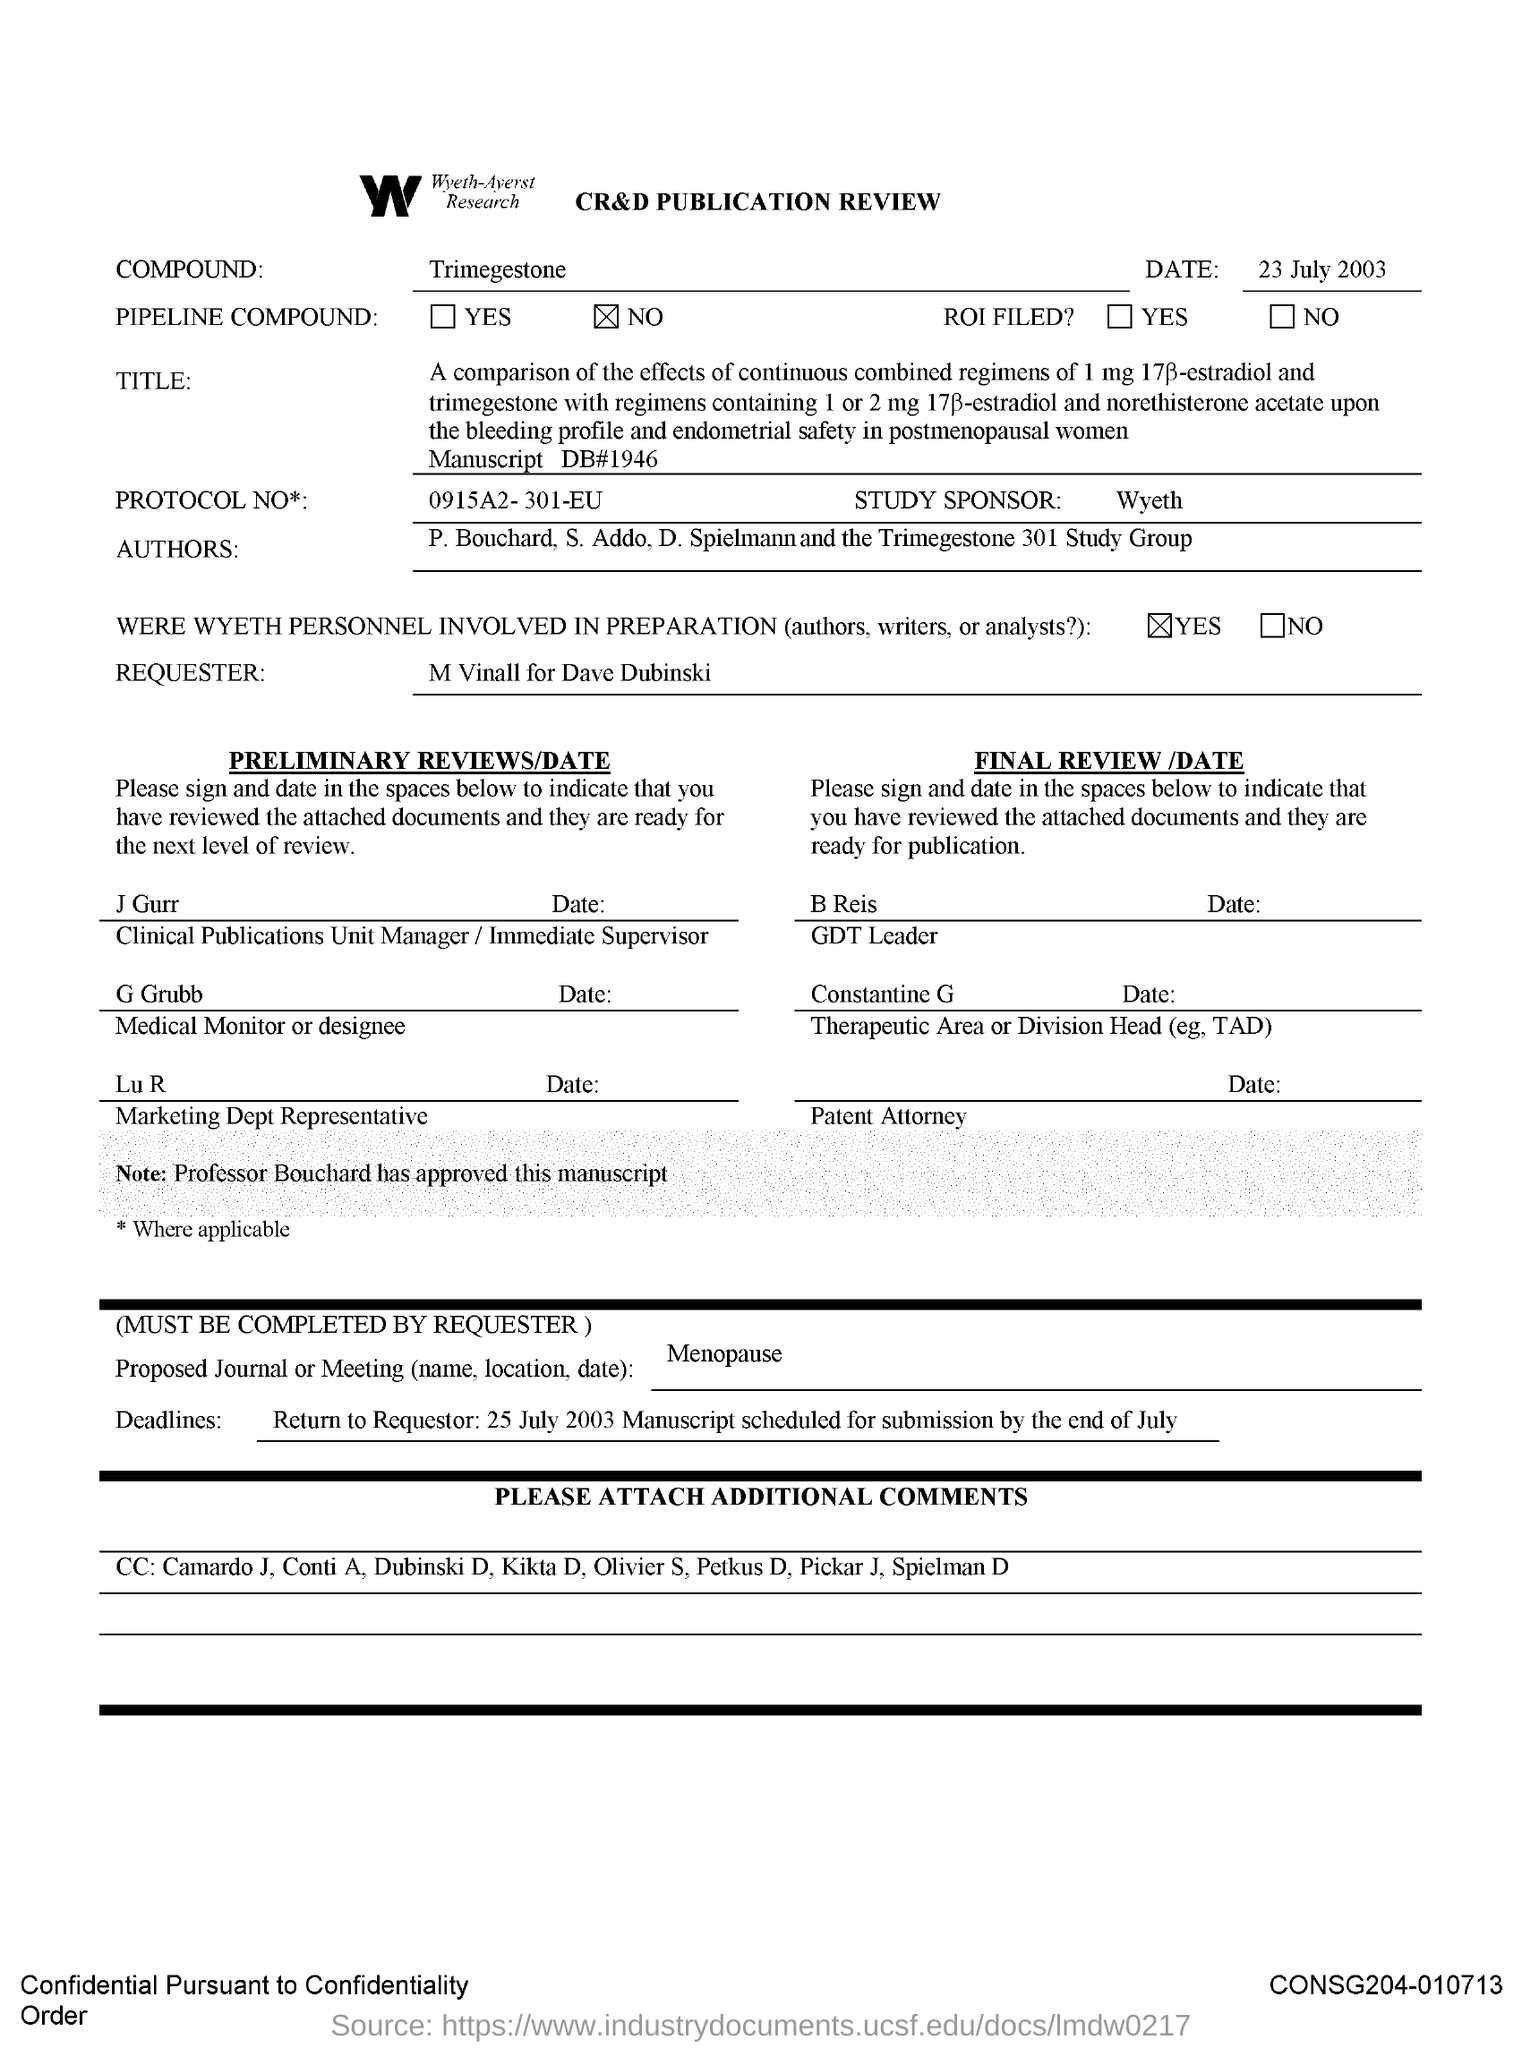What is the Date?
Give a very brief answer. 23 July 2003. What is the compound?
Your response must be concise. Trimegestone. Who is the study sponsor?
Ensure brevity in your answer.  Wyeth. 